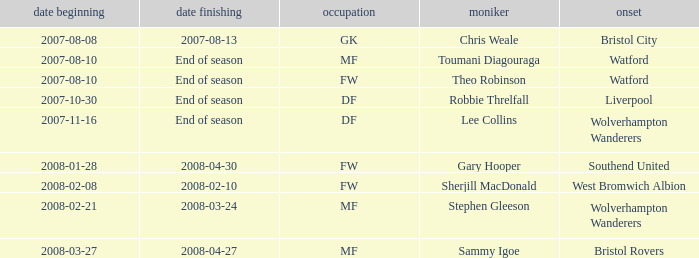What was the from for the Date From of 2007-08-08? Bristol City. 